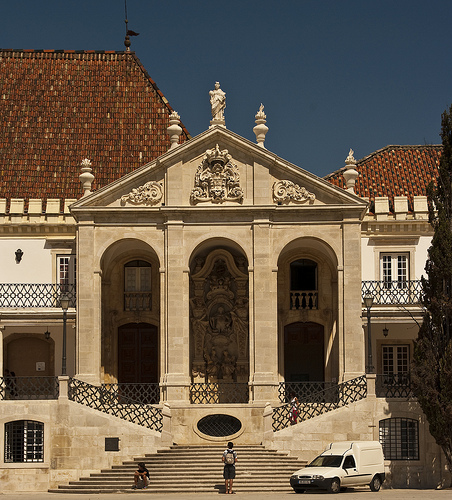<image>
Is there a statue in the brick roof? No. The statue is not contained within the brick roof. These objects have a different spatial relationship. 